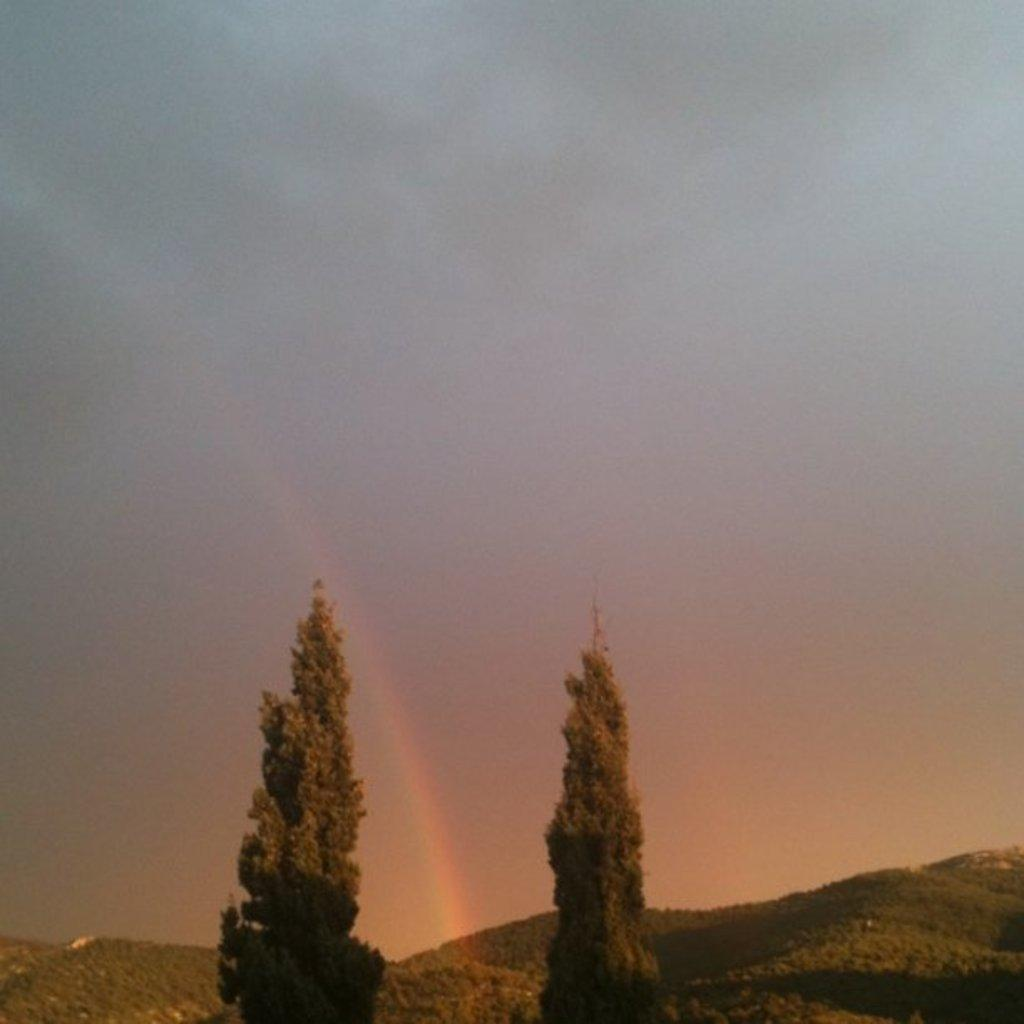What type of natural vegetation can be seen in the image? There are trees in the image. What geographical feature is present in the image? There are mountains in the image. What part of the natural environment is visible in the image? The sky is visible in the image. What type of fowl can be seen perched on the scarecrow in the image? There is no fowl or scarecrow present in the image; it features trees, mountains, and the sky. 